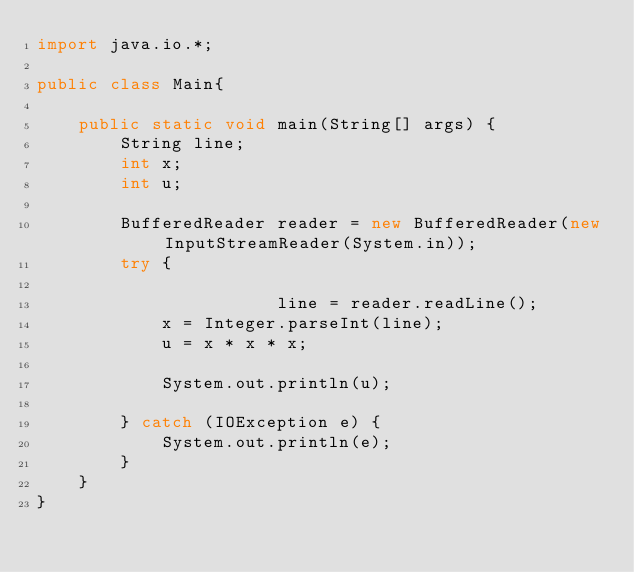Convert code to text. <code><loc_0><loc_0><loc_500><loc_500><_Java_>import java.io.*;

public class Main{

    public static void main(String[] args) {
        String line;
        int x;
        int u;

        BufferedReader reader = new BufferedReader(new InputStreamReader(System.in));
        try {

                       line = reader.readLine();
            x = Integer.parseInt(line);
            u = x * x * x;

            System.out.println(u);

        } catch (IOException e) {
            System.out.println(e);
        }
    }
}
</code> 